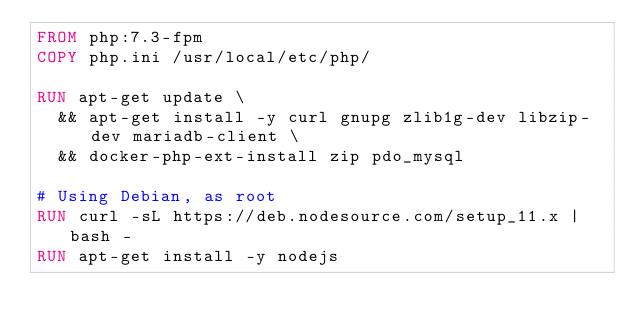<code> <loc_0><loc_0><loc_500><loc_500><_Dockerfile_>FROM php:7.3-fpm
COPY php.ini /usr/local/etc/php/

RUN apt-get update \
  && apt-get install -y curl gnupg zlib1g-dev libzip-dev mariadb-client \
  && docker-php-ext-install zip pdo_mysql

# Using Debian, as root
RUN curl -sL https://deb.nodesource.com/setup_11.x | bash -
RUN apt-get install -y nodejs</code> 